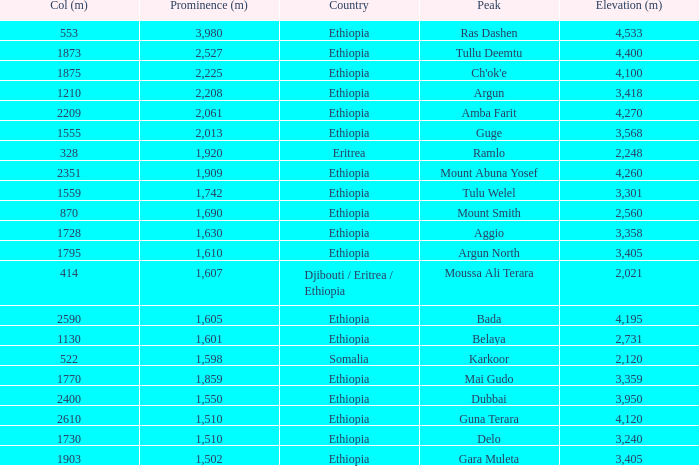What is the sum of the prominence in m of moussa ali terara peak? 1607.0. 